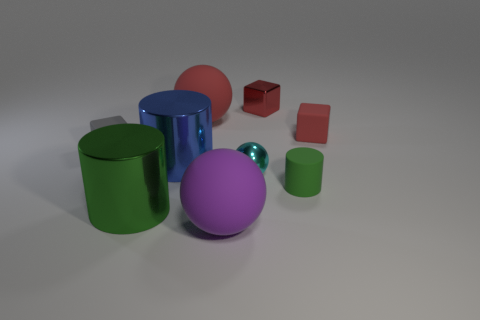Is there anything else that has the same material as the tiny green cylinder?
Give a very brief answer. Yes. What material is the cyan sphere?
Make the answer very short. Metal. What is the material of the green cylinder behind the large green cylinder?
Make the answer very short. Rubber. Are there any other things that have the same color as the shiny block?
Your answer should be compact. Yes. There is a cube that is made of the same material as the cyan object; what is its size?
Your answer should be compact. Small. How many large objects are either spheres or purple spheres?
Your answer should be compact. 2. How big is the shiny cylinder behind the green cylinder that is on the right side of the red object that is on the left side of the purple rubber thing?
Your answer should be very brief. Large. How many purple balls are the same size as the purple matte object?
Your answer should be compact. 0. How many objects are either small red shiny objects or green cylinders on the left side of the large blue cylinder?
Make the answer very short. 2. There is a big purple rubber thing; what shape is it?
Your answer should be very brief. Sphere. 